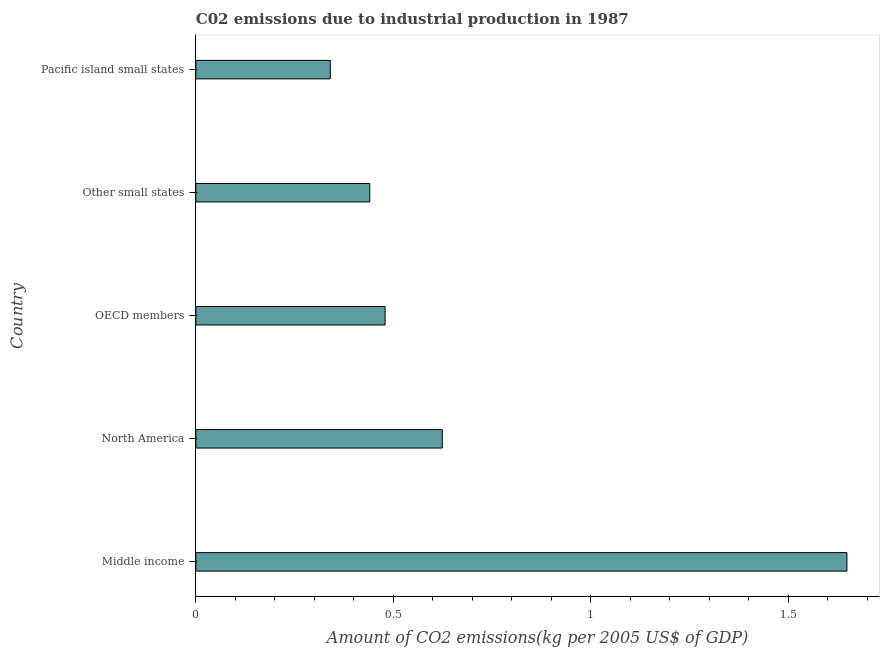Does the graph contain any zero values?
Your answer should be very brief. No. Does the graph contain grids?
Provide a short and direct response. No. What is the title of the graph?
Offer a very short reply. C02 emissions due to industrial production in 1987. What is the label or title of the X-axis?
Your answer should be very brief. Amount of CO2 emissions(kg per 2005 US$ of GDP). What is the amount of co2 emissions in OECD members?
Provide a succinct answer. 0.48. Across all countries, what is the maximum amount of co2 emissions?
Your answer should be very brief. 1.65. Across all countries, what is the minimum amount of co2 emissions?
Offer a terse response. 0.34. In which country was the amount of co2 emissions minimum?
Ensure brevity in your answer.  Pacific island small states. What is the sum of the amount of co2 emissions?
Make the answer very short. 3.53. What is the difference between the amount of co2 emissions in Middle income and Pacific island small states?
Provide a short and direct response. 1.31. What is the average amount of co2 emissions per country?
Your answer should be very brief. 0.71. What is the median amount of co2 emissions?
Provide a short and direct response. 0.48. In how many countries, is the amount of co2 emissions greater than 0.8 kg per 2005 US$ of GDP?
Provide a succinct answer. 1. What is the ratio of the amount of co2 emissions in Middle income to that in North America?
Keep it short and to the point. 2.64. Is the difference between the amount of co2 emissions in Middle income and Pacific island small states greater than the difference between any two countries?
Keep it short and to the point. Yes. What is the difference between the highest and the second highest amount of co2 emissions?
Provide a succinct answer. 1.02. Is the sum of the amount of co2 emissions in North America and Other small states greater than the maximum amount of co2 emissions across all countries?
Your answer should be compact. No. What is the difference between the highest and the lowest amount of co2 emissions?
Provide a succinct answer. 1.31. How many bars are there?
Your answer should be compact. 5. Are all the bars in the graph horizontal?
Offer a terse response. Yes. How many countries are there in the graph?
Your response must be concise. 5. What is the difference between two consecutive major ticks on the X-axis?
Give a very brief answer. 0.5. What is the Amount of CO2 emissions(kg per 2005 US$ of GDP) of Middle income?
Keep it short and to the point. 1.65. What is the Amount of CO2 emissions(kg per 2005 US$ of GDP) of North America?
Provide a succinct answer. 0.62. What is the Amount of CO2 emissions(kg per 2005 US$ of GDP) of OECD members?
Provide a succinct answer. 0.48. What is the Amount of CO2 emissions(kg per 2005 US$ of GDP) of Other small states?
Provide a short and direct response. 0.44. What is the Amount of CO2 emissions(kg per 2005 US$ of GDP) in Pacific island small states?
Ensure brevity in your answer.  0.34. What is the difference between the Amount of CO2 emissions(kg per 2005 US$ of GDP) in Middle income and North America?
Your answer should be very brief. 1.02. What is the difference between the Amount of CO2 emissions(kg per 2005 US$ of GDP) in Middle income and OECD members?
Your answer should be compact. 1.17. What is the difference between the Amount of CO2 emissions(kg per 2005 US$ of GDP) in Middle income and Other small states?
Your response must be concise. 1.21. What is the difference between the Amount of CO2 emissions(kg per 2005 US$ of GDP) in Middle income and Pacific island small states?
Your response must be concise. 1.31. What is the difference between the Amount of CO2 emissions(kg per 2005 US$ of GDP) in North America and OECD members?
Offer a terse response. 0.14. What is the difference between the Amount of CO2 emissions(kg per 2005 US$ of GDP) in North America and Other small states?
Your response must be concise. 0.18. What is the difference between the Amount of CO2 emissions(kg per 2005 US$ of GDP) in North America and Pacific island small states?
Provide a short and direct response. 0.28. What is the difference between the Amount of CO2 emissions(kg per 2005 US$ of GDP) in OECD members and Other small states?
Ensure brevity in your answer.  0.04. What is the difference between the Amount of CO2 emissions(kg per 2005 US$ of GDP) in OECD members and Pacific island small states?
Offer a very short reply. 0.14. What is the difference between the Amount of CO2 emissions(kg per 2005 US$ of GDP) in Other small states and Pacific island small states?
Make the answer very short. 0.1. What is the ratio of the Amount of CO2 emissions(kg per 2005 US$ of GDP) in Middle income to that in North America?
Ensure brevity in your answer.  2.64. What is the ratio of the Amount of CO2 emissions(kg per 2005 US$ of GDP) in Middle income to that in OECD members?
Make the answer very short. 3.44. What is the ratio of the Amount of CO2 emissions(kg per 2005 US$ of GDP) in Middle income to that in Other small states?
Your response must be concise. 3.74. What is the ratio of the Amount of CO2 emissions(kg per 2005 US$ of GDP) in Middle income to that in Pacific island small states?
Keep it short and to the point. 4.84. What is the ratio of the Amount of CO2 emissions(kg per 2005 US$ of GDP) in North America to that in OECD members?
Keep it short and to the point. 1.3. What is the ratio of the Amount of CO2 emissions(kg per 2005 US$ of GDP) in North America to that in Other small states?
Your response must be concise. 1.42. What is the ratio of the Amount of CO2 emissions(kg per 2005 US$ of GDP) in North America to that in Pacific island small states?
Provide a succinct answer. 1.83. What is the ratio of the Amount of CO2 emissions(kg per 2005 US$ of GDP) in OECD members to that in Other small states?
Offer a terse response. 1.09. What is the ratio of the Amount of CO2 emissions(kg per 2005 US$ of GDP) in OECD members to that in Pacific island small states?
Give a very brief answer. 1.41. What is the ratio of the Amount of CO2 emissions(kg per 2005 US$ of GDP) in Other small states to that in Pacific island small states?
Ensure brevity in your answer.  1.29. 